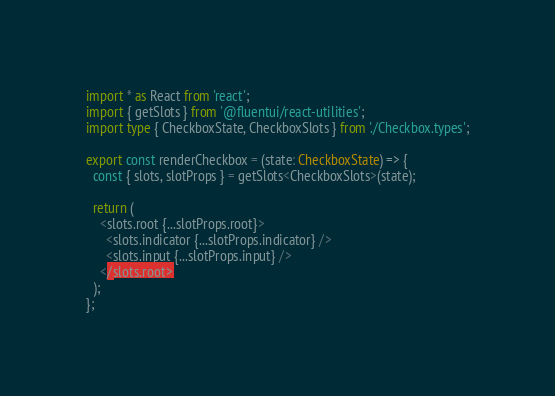Convert code to text. <code><loc_0><loc_0><loc_500><loc_500><_TypeScript_>import * as React from 'react';
import { getSlots } from '@fluentui/react-utilities';
import type { CheckboxState, CheckboxSlots } from './Checkbox.types';

export const renderCheckbox = (state: CheckboxState) => {
  const { slots, slotProps } = getSlots<CheckboxSlots>(state);

  return (
    <slots.root {...slotProps.root}>
      <slots.indicator {...slotProps.indicator} />
      <slots.input {...slotProps.input} />
    </slots.root>
  );
};
</code> 